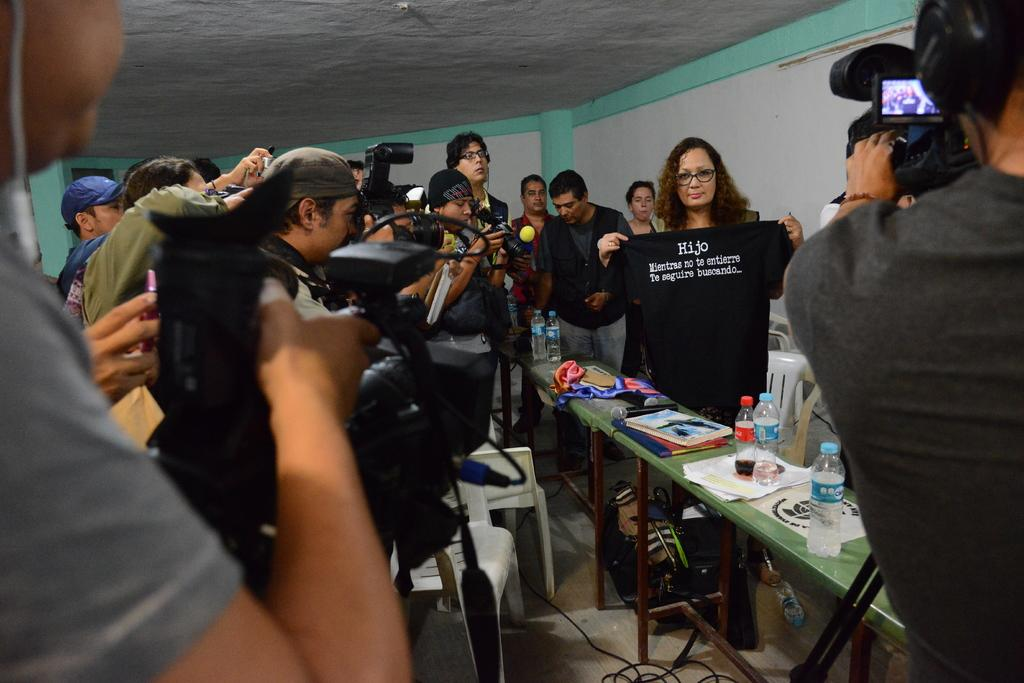How many people are in the image? There is a group of persons in the image, but the exact number is not specified. Where are the persons located in the image? The group of persons is standing in a room. What are the persons doing in the image? The group of persons is taking photographs. What is the object being photographed in the image? The object being photographed is a black color shirt. What type of sign is hanging on the gate in the image? There is no gate or sign present in the image. 